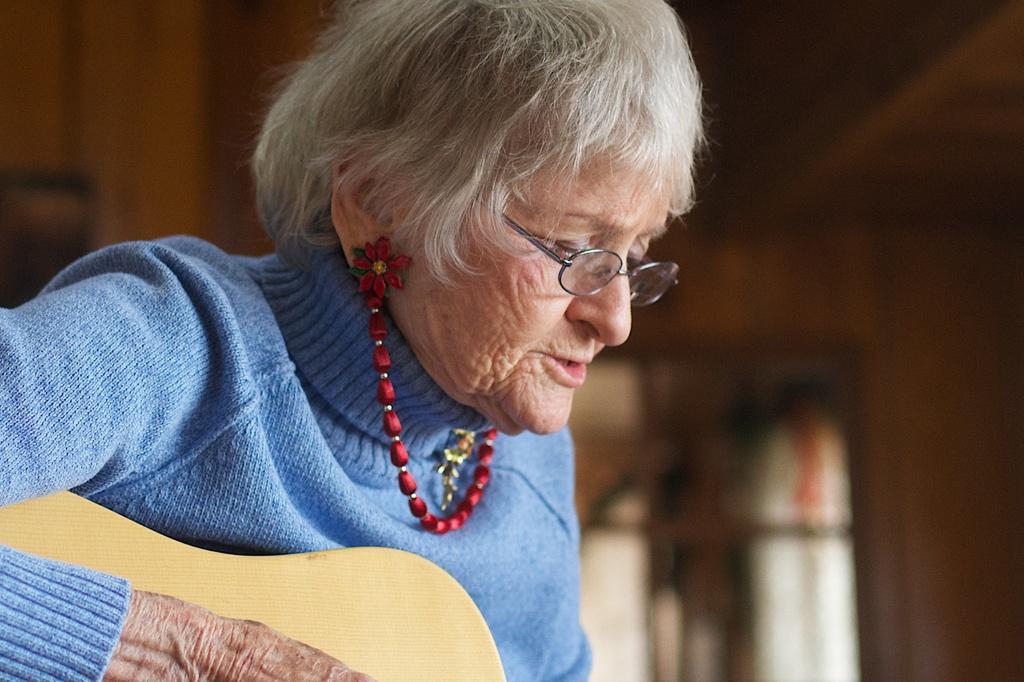Can you describe this image briefly? This image consists of a woman who is wearing blue color dress and red chain. She is holding a guitar and she is playing it. She is wearing specs. 